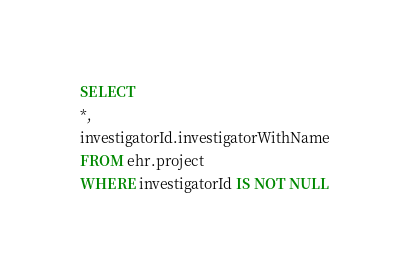<code> <loc_0><loc_0><loc_500><loc_500><_SQL_>SELECT
*,
investigatorId.investigatorWithName
FROM ehr.project
WHERE investigatorId IS NOT NULL</code> 